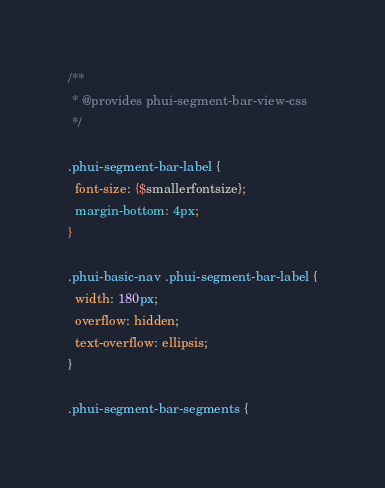<code> <loc_0><loc_0><loc_500><loc_500><_CSS_>/**
 * @provides phui-segment-bar-view-css
 */

.phui-segment-bar-label {
  font-size: {$smallerfontsize};
  margin-bottom: 4px;
}

.phui-basic-nav .phui-segment-bar-label {
  width: 180px;
  overflow: hidden;
  text-overflow: ellipsis;
}

.phui-segment-bar-segments {</code> 